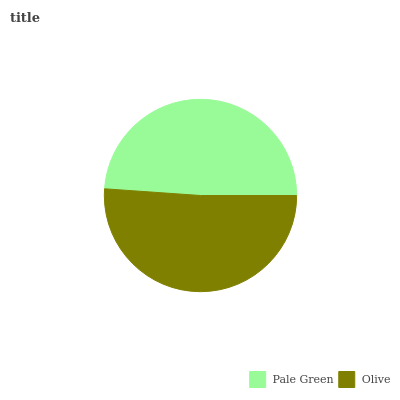Is Pale Green the minimum?
Answer yes or no. Yes. Is Olive the maximum?
Answer yes or no. Yes. Is Olive the minimum?
Answer yes or no. No. Is Olive greater than Pale Green?
Answer yes or no. Yes. Is Pale Green less than Olive?
Answer yes or no. Yes. Is Pale Green greater than Olive?
Answer yes or no. No. Is Olive less than Pale Green?
Answer yes or no. No. Is Olive the high median?
Answer yes or no. Yes. Is Pale Green the low median?
Answer yes or no. Yes. Is Pale Green the high median?
Answer yes or no. No. Is Olive the low median?
Answer yes or no. No. 